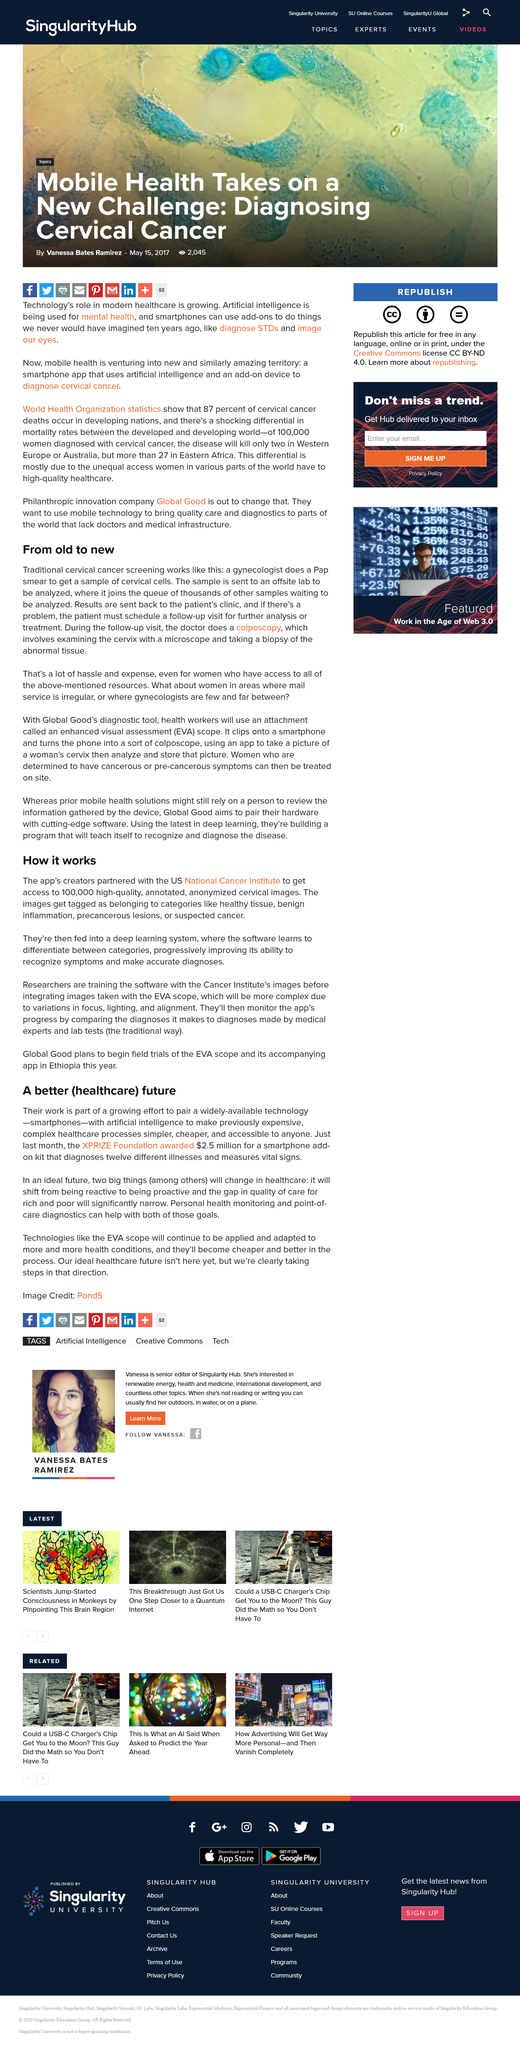Indicate a few pertinent items in this graphic. The article mentions a specific scope with an abbreviation of three letters, specifically EVA. The title of the article is "How it Works". The researchers will monitor the app's progress by comparing its diagnoses to those made by medical experts and lab tests. A traditional cervical cancer screening involves a gynaecologist obtaining a sample of cervical cells through a Pap smear in order to detect any abnormalities or potential cancerous growths. The researchers are training the software with the Cancer Institute's images. 